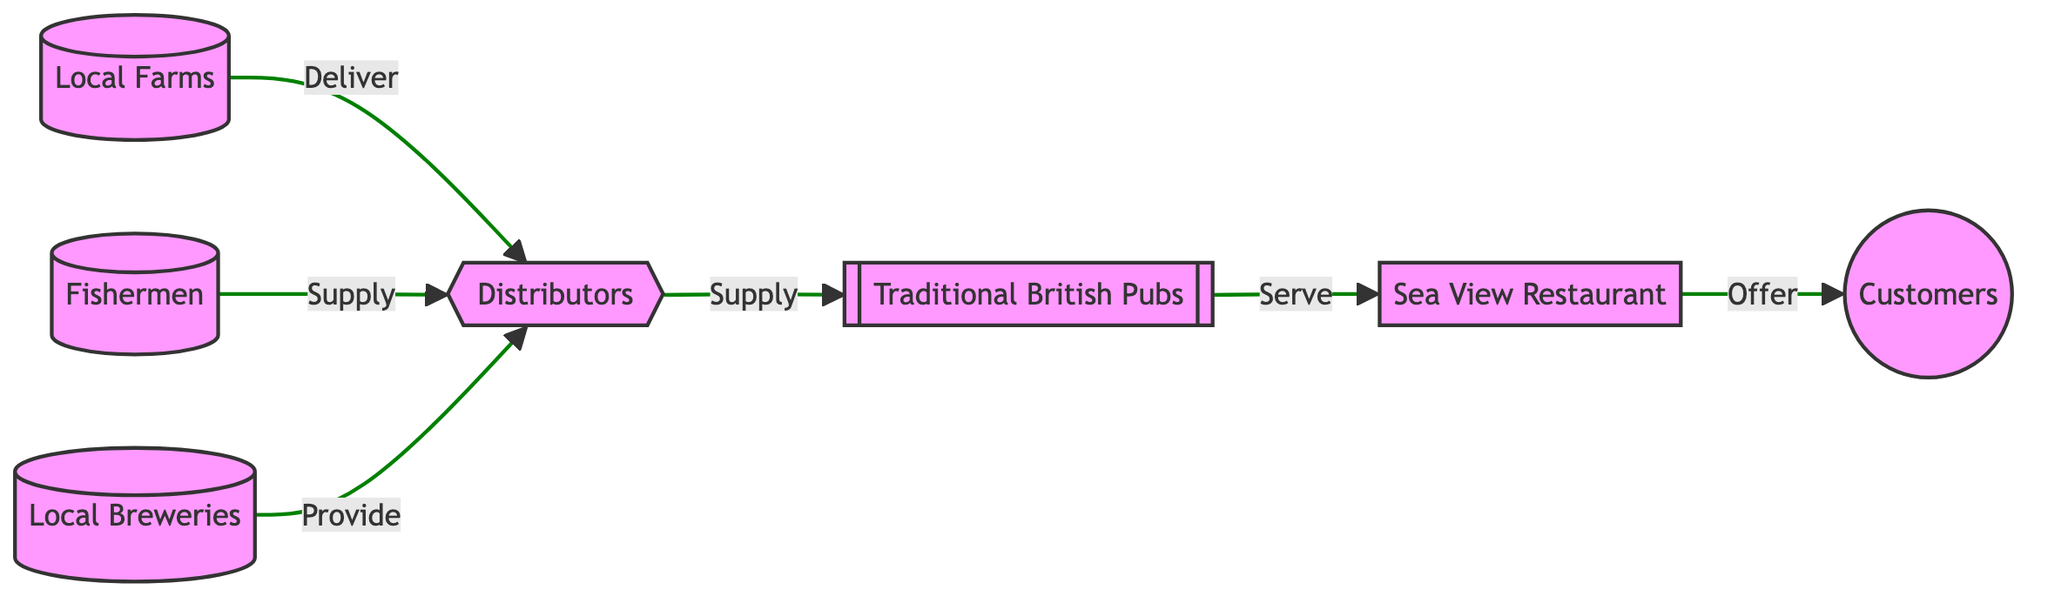What are the starting points in the supply chain? The diagram begins with "Local Farms," "Fishermen," and "Local Breweries." These are the initial contributors to the supply chain, supplying goods to the distributors.
Answer: Local Farms, Fishermen, Local Breweries How many types of suppliers are there? The diagram features three types of suppliers: "Local Farms," "Fishermen," and "Local Breweries." Each type plays a distinct role in the supply chain.
Answer: Three What role do distributors play in the supply chain? Distributors act as intermediaries that supply products to traditional British pubs, gathering goods from the various suppliers shown in the diagram.
Answer: Supply Which entities are involved after the distributors? After the distributors, the entities involved are "Traditional British Pubs" and "Sea View Restaurant," which both serve customers.
Answer: Traditional British Pubs, Sea View Restaurant Who are the final customers in the supply chain? The final customers in the chain are represented simply as "Customers," receiving the services and products offered by the restaurants and pubs.
Answer: Customers What is the relationship between "Traditional British Pubs" and "Sea View Restaurant"? "Traditional British Pubs" serve their products to "Sea View Restaurant," which then offers these to the customers. This connection indicates collaboration in serving the same customer base.
Answer: Serve How do local farms connect to customers in this chain? Local farms supply their products to distributors, who then supply traditional pubs and the Sea View Restaurant. Hence, customers receive these farm products through those establishments.
Answer: Through distributors What type of diagram is represented here? This is a flowchart depicting a food chain, showcasing the connections and relationships between various entities in the traditional British pub supply chain.
Answer: Flowchart 